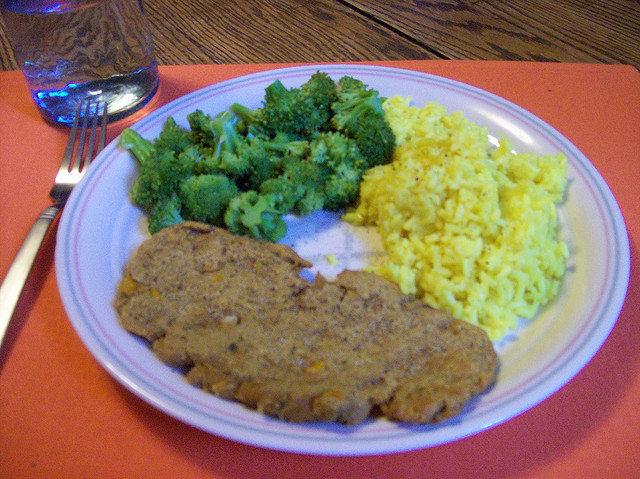What kind of meal is this considered, and when might it be typically eaten? This appears to be a traditional American-style meal that could be served for either lunch or dinner. The combination of meatloaf, vegetables, and rice provides a balanced mix of protein, fiber, and carbohydrates. 